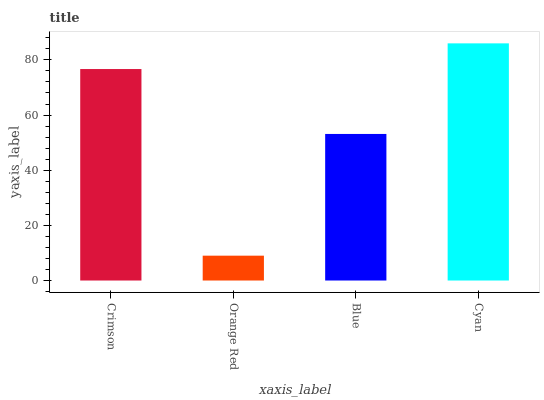Is Orange Red the minimum?
Answer yes or no. Yes. Is Cyan the maximum?
Answer yes or no. Yes. Is Blue the minimum?
Answer yes or no. No. Is Blue the maximum?
Answer yes or no. No. Is Blue greater than Orange Red?
Answer yes or no. Yes. Is Orange Red less than Blue?
Answer yes or no. Yes. Is Orange Red greater than Blue?
Answer yes or no. No. Is Blue less than Orange Red?
Answer yes or no. No. Is Crimson the high median?
Answer yes or no. Yes. Is Blue the low median?
Answer yes or no. Yes. Is Blue the high median?
Answer yes or no. No. Is Orange Red the low median?
Answer yes or no. No. 